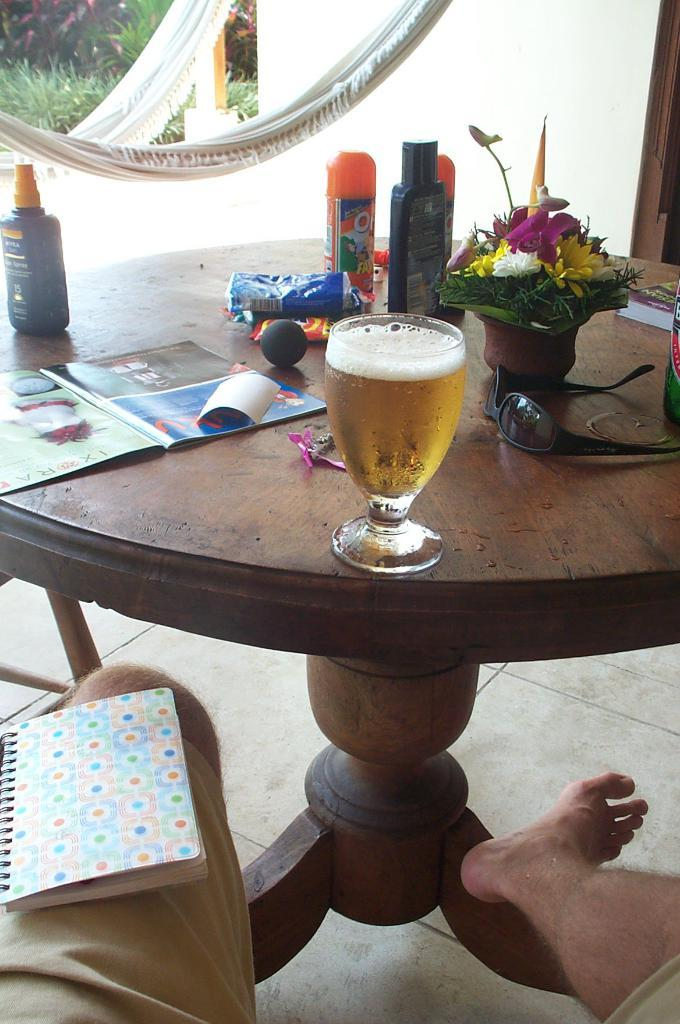What piece of furniture is present in the image? There is a table in the image. What can be seen on the table? There is a glass, a book, bottles, goggles, and a flower vase on the table. Can you describe the floor in the image? The floor is visible in the image. What else can be seen on the floor besides the table? There is a book on the floor. What type of smile can be seen on the airport in the image? There is no airport present in the image, and therefore no smile can be observed. What division of mathematics is being practiced in the image? There is no indication of any mathematical activity in the image. 